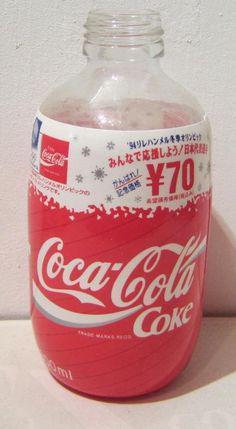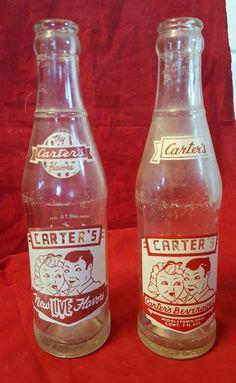The first image is the image on the left, the second image is the image on the right. Assess this claim about the two images: "There are two bottles in the image on the left and half that in the image on the right.". Correct or not? Answer yes or no. No. The first image is the image on the left, the second image is the image on the right. Examine the images to the left and right. Is the description "All the bottles are filled with a dark liquid." accurate? Answer yes or no. No. 